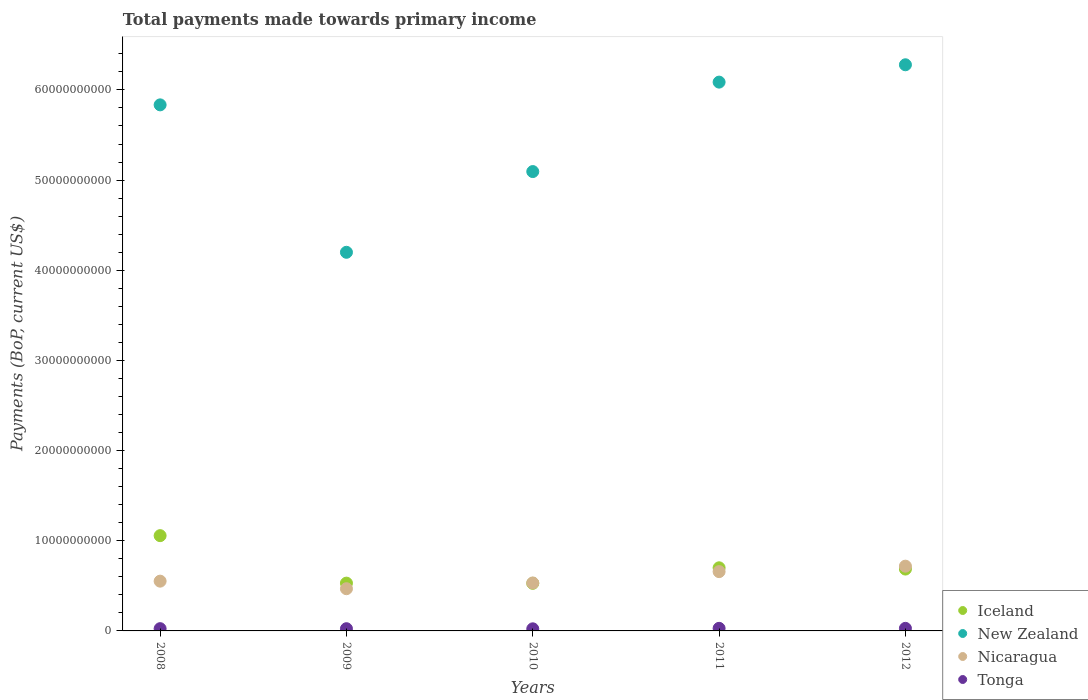What is the total payments made towards primary income in New Zealand in 2009?
Make the answer very short. 4.20e+1. Across all years, what is the maximum total payments made towards primary income in Tonga?
Your answer should be very brief. 2.87e+08. Across all years, what is the minimum total payments made towards primary income in New Zealand?
Make the answer very short. 4.20e+1. What is the total total payments made towards primary income in New Zealand in the graph?
Offer a very short reply. 2.75e+11. What is the difference between the total payments made towards primary income in Iceland in 2008 and that in 2009?
Provide a succinct answer. 5.27e+09. What is the difference between the total payments made towards primary income in Nicaragua in 2011 and the total payments made towards primary income in Tonga in 2012?
Provide a succinct answer. 6.29e+09. What is the average total payments made towards primary income in New Zealand per year?
Provide a succinct answer. 5.50e+1. In the year 2009, what is the difference between the total payments made towards primary income in New Zealand and total payments made towards primary income in Nicaragua?
Provide a succinct answer. 3.73e+1. What is the ratio of the total payments made towards primary income in Tonga in 2009 to that in 2012?
Make the answer very short. 0.86. Is the difference between the total payments made towards primary income in New Zealand in 2010 and 2012 greater than the difference between the total payments made towards primary income in Nicaragua in 2010 and 2012?
Provide a short and direct response. No. What is the difference between the highest and the second highest total payments made towards primary income in Tonga?
Keep it short and to the point. 2.66e+06. What is the difference between the highest and the lowest total payments made towards primary income in New Zealand?
Your answer should be very brief. 2.08e+1. Is the sum of the total payments made towards primary income in Nicaragua in 2010 and 2011 greater than the maximum total payments made towards primary income in Tonga across all years?
Keep it short and to the point. Yes. Is it the case that in every year, the sum of the total payments made towards primary income in New Zealand and total payments made towards primary income in Iceland  is greater than the total payments made towards primary income in Tonga?
Provide a succinct answer. Yes. Does the total payments made towards primary income in New Zealand monotonically increase over the years?
Your answer should be compact. No. How many dotlines are there?
Your answer should be compact. 4. How many years are there in the graph?
Offer a terse response. 5. Does the graph contain grids?
Provide a succinct answer. No. Where does the legend appear in the graph?
Your response must be concise. Bottom right. How are the legend labels stacked?
Give a very brief answer. Vertical. What is the title of the graph?
Provide a succinct answer. Total payments made towards primary income. Does "Vietnam" appear as one of the legend labels in the graph?
Keep it short and to the point. No. What is the label or title of the X-axis?
Ensure brevity in your answer.  Years. What is the label or title of the Y-axis?
Provide a succinct answer. Payments (BoP, current US$). What is the Payments (BoP, current US$) in Iceland in 2008?
Make the answer very short. 1.06e+1. What is the Payments (BoP, current US$) in New Zealand in 2008?
Offer a terse response. 5.83e+1. What is the Payments (BoP, current US$) of Nicaragua in 2008?
Give a very brief answer. 5.52e+09. What is the Payments (BoP, current US$) in Tonga in 2008?
Your answer should be compact. 2.51e+08. What is the Payments (BoP, current US$) of Iceland in 2009?
Give a very brief answer. 5.30e+09. What is the Payments (BoP, current US$) of New Zealand in 2009?
Keep it short and to the point. 4.20e+1. What is the Payments (BoP, current US$) of Nicaragua in 2009?
Ensure brevity in your answer.  4.68e+09. What is the Payments (BoP, current US$) in Tonga in 2009?
Your answer should be compact. 2.45e+08. What is the Payments (BoP, current US$) of Iceland in 2010?
Offer a terse response. 5.28e+09. What is the Payments (BoP, current US$) of New Zealand in 2010?
Make the answer very short. 5.09e+1. What is the Payments (BoP, current US$) in Nicaragua in 2010?
Your response must be concise. 5.32e+09. What is the Payments (BoP, current US$) of Tonga in 2010?
Offer a terse response. 2.33e+08. What is the Payments (BoP, current US$) in Iceland in 2011?
Provide a short and direct response. 7.00e+09. What is the Payments (BoP, current US$) of New Zealand in 2011?
Offer a terse response. 6.09e+1. What is the Payments (BoP, current US$) of Nicaragua in 2011?
Your answer should be very brief. 6.58e+09. What is the Payments (BoP, current US$) in Tonga in 2011?
Provide a succinct answer. 2.87e+08. What is the Payments (BoP, current US$) in Iceland in 2012?
Make the answer very short. 6.86e+09. What is the Payments (BoP, current US$) of New Zealand in 2012?
Offer a terse response. 6.28e+1. What is the Payments (BoP, current US$) of Nicaragua in 2012?
Provide a short and direct response. 7.18e+09. What is the Payments (BoP, current US$) of Tonga in 2012?
Your answer should be very brief. 2.85e+08. Across all years, what is the maximum Payments (BoP, current US$) in Iceland?
Provide a succinct answer. 1.06e+1. Across all years, what is the maximum Payments (BoP, current US$) of New Zealand?
Provide a succinct answer. 6.28e+1. Across all years, what is the maximum Payments (BoP, current US$) of Nicaragua?
Provide a succinct answer. 7.18e+09. Across all years, what is the maximum Payments (BoP, current US$) in Tonga?
Ensure brevity in your answer.  2.87e+08. Across all years, what is the minimum Payments (BoP, current US$) in Iceland?
Your answer should be compact. 5.28e+09. Across all years, what is the minimum Payments (BoP, current US$) of New Zealand?
Keep it short and to the point. 4.20e+1. Across all years, what is the minimum Payments (BoP, current US$) of Nicaragua?
Give a very brief answer. 4.68e+09. Across all years, what is the minimum Payments (BoP, current US$) of Tonga?
Your answer should be very brief. 2.33e+08. What is the total Payments (BoP, current US$) of Iceland in the graph?
Your answer should be compact. 3.50e+1. What is the total Payments (BoP, current US$) of New Zealand in the graph?
Your answer should be compact. 2.75e+11. What is the total Payments (BoP, current US$) in Nicaragua in the graph?
Your answer should be compact. 2.93e+1. What is the total Payments (BoP, current US$) in Tonga in the graph?
Offer a terse response. 1.30e+09. What is the difference between the Payments (BoP, current US$) of Iceland in 2008 and that in 2009?
Your answer should be compact. 5.27e+09. What is the difference between the Payments (BoP, current US$) in New Zealand in 2008 and that in 2009?
Your response must be concise. 1.64e+1. What is the difference between the Payments (BoP, current US$) in Nicaragua in 2008 and that in 2009?
Keep it short and to the point. 8.38e+08. What is the difference between the Payments (BoP, current US$) of Tonga in 2008 and that in 2009?
Provide a succinct answer. 5.78e+06. What is the difference between the Payments (BoP, current US$) of Iceland in 2008 and that in 2010?
Provide a short and direct response. 5.29e+09. What is the difference between the Payments (BoP, current US$) in New Zealand in 2008 and that in 2010?
Your answer should be very brief. 7.40e+09. What is the difference between the Payments (BoP, current US$) in Nicaragua in 2008 and that in 2010?
Provide a short and direct response. 2.00e+08. What is the difference between the Payments (BoP, current US$) of Tonga in 2008 and that in 2010?
Keep it short and to the point. 1.86e+07. What is the difference between the Payments (BoP, current US$) in Iceland in 2008 and that in 2011?
Keep it short and to the point. 3.57e+09. What is the difference between the Payments (BoP, current US$) of New Zealand in 2008 and that in 2011?
Provide a succinct answer. -2.52e+09. What is the difference between the Payments (BoP, current US$) in Nicaragua in 2008 and that in 2011?
Ensure brevity in your answer.  -1.06e+09. What is the difference between the Payments (BoP, current US$) in Tonga in 2008 and that in 2011?
Give a very brief answer. -3.60e+07. What is the difference between the Payments (BoP, current US$) in Iceland in 2008 and that in 2012?
Your answer should be compact. 3.71e+09. What is the difference between the Payments (BoP, current US$) of New Zealand in 2008 and that in 2012?
Ensure brevity in your answer.  -4.45e+09. What is the difference between the Payments (BoP, current US$) in Nicaragua in 2008 and that in 2012?
Give a very brief answer. -1.66e+09. What is the difference between the Payments (BoP, current US$) in Tonga in 2008 and that in 2012?
Provide a short and direct response. -3.34e+07. What is the difference between the Payments (BoP, current US$) of Iceland in 2009 and that in 2010?
Ensure brevity in your answer.  2.02e+07. What is the difference between the Payments (BoP, current US$) in New Zealand in 2009 and that in 2010?
Give a very brief answer. -8.95e+09. What is the difference between the Payments (BoP, current US$) of Nicaragua in 2009 and that in 2010?
Offer a terse response. -6.38e+08. What is the difference between the Payments (BoP, current US$) in Tonga in 2009 and that in 2010?
Give a very brief answer. 1.28e+07. What is the difference between the Payments (BoP, current US$) of Iceland in 2009 and that in 2011?
Your answer should be compact. -1.70e+09. What is the difference between the Payments (BoP, current US$) in New Zealand in 2009 and that in 2011?
Provide a succinct answer. -1.89e+1. What is the difference between the Payments (BoP, current US$) in Nicaragua in 2009 and that in 2011?
Make the answer very short. -1.90e+09. What is the difference between the Payments (BoP, current US$) in Tonga in 2009 and that in 2011?
Provide a short and direct response. -4.18e+07. What is the difference between the Payments (BoP, current US$) in Iceland in 2009 and that in 2012?
Provide a succinct answer. -1.56e+09. What is the difference between the Payments (BoP, current US$) of New Zealand in 2009 and that in 2012?
Provide a short and direct response. -2.08e+1. What is the difference between the Payments (BoP, current US$) of Nicaragua in 2009 and that in 2012?
Your answer should be very brief. -2.50e+09. What is the difference between the Payments (BoP, current US$) in Tonga in 2009 and that in 2012?
Offer a terse response. -3.91e+07. What is the difference between the Payments (BoP, current US$) of Iceland in 2010 and that in 2011?
Keep it short and to the point. -1.72e+09. What is the difference between the Payments (BoP, current US$) in New Zealand in 2010 and that in 2011?
Give a very brief answer. -9.92e+09. What is the difference between the Payments (BoP, current US$) of Nicaragua in 2010 and that in 2011?
Offer a very short reply. -1.26e+09. What is the difference between the Payments (BoP, current US$) of Tonga in 2010 and that in 2011?
Provide a succinct answer. -5.46e+07. What is the difference between the Payments (BoP, current US$) of Iceland in 2010 and that in 2012?
Offer a terse response. -1.58e+09. What is the difference between the Payments (BoP, current US$) of New Zealand in 2010 and that in 2012?
Provide a succinct answer. -1.18e+1. What is the difference between the Payments (BoP, current US$) in Nicaragua in 2010 and that in 2012?
Your answer should be compact. -1.86e+09. What is the difference between the Payments (BoP, current US$) of Tonga in 2010 and that in 2012?
Offer a terse response. -5.19e+07. What is the difference between the Payments (BoP, current US$) of Iceland in 2011 and that in 2012?
Keep it short and to the point. 1.41e+08. What is the difference between the Payments (BoP, current US$) in New Zealand in 2011 and that in 2012?
Ensure brevity in your answer.  -1.92e+09. What is the difference between the Payments (BoP, current US$) in Nicaragua in 2011 and that in 2012?
Provide a succinct answer. -6.07e+08. What is the difference between the Payments (BoP, current US$) of Tonga in 2011 and that in 2012?
Offer a very short reply. 2.66e+06. What is the difference between the Payments (BoP, current US$) of Iceland in 2008 and the Payments (BoP, current US$) of New Zealand in 2009?
Your answer should be compact. -3.14e+1. What is the difference between the Payments (BoP, current US$) of Iceland in 2008 and the Payments (BoP, current US$) of Nicaragua in 2009?
Make the answer very short. 5.89e+09. What is the difference between the Payments (BoP, current US$) in Iceland in 2008 and the Payments (BoP, current US$) in Tonga in 2009?
Your answer should be compact. 1.03e+1. What is the difference between the Payments (BoP, current US$) in New Zealand in 2008 and the Payments (BoP, current US$) in Nicaragua in 2009?
Your answer should be compact. 5.37e+1. What is the difference between the Payments (BoP, current US$) in New Zealand in 2008 and the Payments (BoP, current US$) in Tonga in 2009?
Provide a succinct answer. 5.81e+1. What is the difference between the Payments (BoP, current US$) in Nicaragua in 2008 and the Payments (BoP, current US$) in Tonga in 2009?
Ensure brevity in your answer.  5.27e+09. What is the difference between the Payments (BoP, current US$) in Iceland in 2008 and the Payments (BoP, current US$) in New Zealand in 2010?
Give a very brief answer. -4.04e+1. What is the difference between the Payments (BoP, current US$) in Iceland in 2008 and the Payments (BoP, current US$) in Nicaragua in 2010?
Offer a very short reply. 5.25e+09. What is the difference between the Payments (BoP, current US$) of Iceland in 2008 and the Payments (BoP, current US$) of Tonga in 2010?
Give a very brief answer. 1.03e+1. What is the difference between the Payments (BoP, current US$) in New Zealand in 2008 and the Payments (BoP, current US$) in Nicaragua in 2010?
Your answer should be very brief. 5.30e+1. What is the difference between the Payments (BoP, current US$) of New Zealand in 2008 and the Payments (BoP, current US$) of Tonga in 2010?
Keep it short and to the point. 5.81e+1. What is the difference between the Payments (BoP, current US$) of Nicaragua in 2008 and the Payments (BoP, current US$) of Tonga in 2010?
Keep it short and to the point. 5.29e+09. What is the difference between the Payments (BoP, current US$) in Iceland in 2008 and the Payments (BoP, current US$) in New Zealand in 2011?
Your answer should be very brief. -5.03e+1. What is the difference between the Payments (BoP, current US$) of Iceland in 2008 and the Payments (BoP, current US$) of Nicaragua in 2011?
Give a very brief answer. 3.99e+09. What is the difference between the Payments (BoP, current US$) in Iceland in 2008 and the Payments (BoP, current US$) in Tonga in 2011?
Provide a succinct answer. 1.03e+1. What is the difference between the Payments (BoP, current US$) of New Zealand in 2008 and the Payments (BoP, current US$) of Nicaragua in 2011?
Provide a succinct answer. 5.18e+1. What is the difference between the Payments (BoP, current US$) of New Zealand in 2008 and the Payments (BoP, current US$) of Tonga in 2011?
Make the answer very short. 5.81e+1. What is the difference between the Payments (BoP, current US$) of Nicaragua in 2008 and the Payments (BoP, current US$) of Tonga in 2011?
Make the answer very short. 5.23e+09. What is the difference between the Payments (BoP, current US$) of Iceland in 2008 and the Payments (BoP, current US$) of New Zealand in 2012?
Offer a very short reply. -5.22e+1. What is the difference between the Payments (BoP, current US$) of Iceland in 2008 and the Payments (BoP, current US$) of Nicaragua in 2012?
Provide a short and direct response. 3.38e+09. What is the difference between the Payments (BoP, current US$) in Iceland in 2008 and the Payments (BoP, current US$) in Tonga in 2012?
Your answer should be compact. 1.03e+1. What is the difference between the Payments (BoP, current US$) in New Zealand in 2008 and the Payments (BoP, current US$) in Nicaragua in 2012?
Provide a short and direct response. 5.12e+1. What is the difference between the Payments (BoP, current US$) in New Zealand in 2008 and the Payments (BoP, current US$) in Tonga in 2012?
Offer a terse response. 5.81e+1. What is the difference between the Payments (BoP, current US$) of Nicaragua in 2008 and the Payments (BoP, current US$) of Tonga in 2012?
Make the answer very short. 5.23e+09. What is the difference between the Payments (BoP, current US$) in Iceland in 2009 and the Payments (BoP, current US$) in New Zealand in 2010?
Give a very brief answer. -4.56e+1. What is the difference between the Payments (BoP, current US$) in Iceland in 2009 and the Payments (BoP, current US$) in Nicaragua in 2010?
Ensure brevity in your answer.  -1.92e+07. What is the difference between the Payments (BoP, current US$) of Iceland in 2009 and the Payments (BoP, current US$) of Tonga in 2010?
Make the answer very short. 5.07e+09. What is the difference between the Payments (BoP, current US$) of New Zealand in 2009 and the Payments (BoP, current US$) of Nicaragua in 2010?
Make the answer very short. 3.67e+1. What is the difference between the Payments (BoP, current US$) in New Zealand in 2009 and the Payments (BoP, current US$) in Tonga in 2010?
Make the answer very short. 4.18e+1. What is the difference between the Payments (BoP, current US$) of Nicaragua in 2009 and the Payments (BoP, current US$) of Tonga in 2010?
Provide a short and direct response. 4.45e+09. What is the difference between the Payments (BoP, current US$) in Iceland in 2009 and the Payments (BoP, current US$) in New Zealand in 2011?
Make the answer very short. -5.56e+1. What is the difference between the Payments (BoP, current US$) of Iceland in 2009 and the Payments (BoP, current US$) of Nicaragua in 2011?
Give a very brief answer. -1.28e+09. What is the difference between the Payments (BoP, current US$) of Iceland in 2009 and the Payments (BoP, current US$) of Tonga in 2011?
Offer a terse response. 5.01e+09. What is the difference between the Payments (BoP, current US$) of New Zealand in 2009 and the Payments (BoP, current US$) of Nicaragua in 2011?
Your answer should be very brief. 3.54e+1. What is the difference between the Payments (BoP, current US$) in New Zealand in 2009 and the Payments (BoP, current US$) in Tonga in 2011?
Keep it short and to the point. 4.17e+1. What is the difference between the Payments (BoP, current US$) in Nicaragua in 2009 and the Payments (BoP, current US$) in Tonga in 2011?
Keep it short and to the point. 4.39e+09. What is the difference between the Payments (BoP, current US$) in Iceland in 2009 and the Payments (BoP, current US$) in New Zealand in 2012?
Make the answer very short. -5.75e+1. What is the difference between the Payments (BoP, current US$) of Iceland in 2009 and the Payments (BoP, current US$) of Nicaragua in 2012?
Make the answer very short. -1.88e+09. What is the difference between the Payments (BoP, current US$) of Iceland in 2009 and the Payments (BoP, current US$) of Tonga in 2012?
Provide a succinct answer. 5.02e+09. What is the difference between the Payments (BoP, current US$) in New Zealand in 2009 and the Payments (BoP, current US$) in Nicaragua in 2012?
Ensure brevity in your answer.  3.48e+1. What is the difference between the Payments (BoP, current US$) in New Zealand in 2009 and the Payments (BoP, current US$) in Tonga in 2012?
Provide a succinct answer. 4.17e+1. What is the difference between the Payments (BoP, current US$) of Nicaragua in 2009 and the Payments (BoP, current US$) of Tonga in 2012?
Your response must be concise. 4.40e+09. What is the difference between the Payments (BoP, current US$) of Iceland in 2010 and the Payments (BoP, current US$) of New Zealand in 2011?
Keep it short and to the point. -5.56e+1. What is the difference between the Payments (BoP, current US$) in Iceland in 2010 and the Payments (BoP, current US$) in Nicaragua in 2011?
Your answer should be compact. -1.30e+09. What is the difference between the Payments (BoP, current US$) of Iceland in 2010 and the Payments (BoP, current US$) of Tonga in 2011?
Offer a terse response. 4.99e+09. What is the difference between the Payments (BoP, current US$) of New Zealand in 2010 and the Payments (BoP, current US$) of Nicaragua in 2011?
Make the answer very short. 4.44e+1. What is the difference between the Payments (BoP, current US$) in New Zealand in 2010 and the Payments (BoP, current US$) in Tonga in 2011?
Keep it short and to the point. 5.07e+1. What is the difference between the Payments (BoP, current US$) in Nicaragua in 2010 and the Payments (BoP, current US$) in Tonga in 2011?
Your answer should be compact. 5.03e+09. What is the difference between the Payments (BoP, current US$) of Iceland in 2010 and the Payments (BoP, current US$) of New Zealand in 2012?
Provide a short and direct response. -5.75e+1. What is the difference between the Payments (BoP, current US$) of Iceland in 2010 and the Payments (BoP, current US$) of Nicaragua in 2012?
Your answer should be very brief. -1.90e+09. What is the difference between the Payments (BoP, current US$) of Iceland in 2010 and the Payments (BoP, current US$) of Tonga in 2012?
Provide a succinct answer. 5.00e+09. What is the difference between the Payments (BoP, current US$) in New Zealand in 2010 and the Payments (BoP, current US$) in Nicaragua in 2012?
Ensure brevity in your answer.  4.38e+1. What is the difference between the Payments (BoP, current US$) of New Zealand in 2010 and the Payments (BoP, current US$) of Tonga in 2012?
Provide a succinct answer. 5.07e+1. What is the difference between the Payments (BoP, current US$) in Nicaragua in 2010 and the Payments (BoP, current US$) in Tonga in 2012?
Your answer should be compact. 5.03e+09. What is the difference between the Payments (BoP, current US$) in Iceland in 2011 and the Payments (BoP, current US$) in New Zealand in 2012?
Make the answer very short. -5.58e+1. What is the difference between the Payments (BoP, current US$) of Iceland in 2011 and the Payments (BoP, current US$) of Nicaragua in 2012?
Your answer should be very brief. -1.83e+08. What is the difference between the Payments (BoP, current US$) in Iceland in 2011 and the Payments (BoP, current US$) in Tonga in 2012?
Your answer should be very brief. 6.72e+09. What is the difference between the Payments (BoP, current US$) of New Zealand in 2011 and the Payments (BoP, current US$) of Nicaragua in 2012?
Make the answer very short. 5.37e+1. What is the difference between the Payments (BoP, current US$) of New Zealand in 2011 and the Payments (BoP, current US$) of Tonga in 2012?
Keep it short and to the point. 6.06e+1. What is the difference between the Payments (BoP, current US$) in Nicaragua in 2011 and the Payments (BoP, current US$) in Tonga in 2012?
Your answer should be compact. 6.29e+09. What is the average Payments (BoP, current US$) in Iceland per year?
Keep it short and to the point. 7.00e+09. What is the average Payments (BoP, current US$) in New Zealand per year?
Make the answer very short. 5.50e+1. What is the average Payments (BoP, current US$) of Nicaragua per year?
Provide a succinct answer. 5.86e+09. What is the average Payments (BoP, current US$) of Tonga per year?
Give a very brief answer. 2.60e+08. In the year 2008, what is the difference between the Payments (BoP, current US$) in Iceland and Payments (BoP, current US$) in New Zealand?
Provide a short and direct response. -4.78e+1. In the year 2008, what is the difference between the Payments (BoP, current US$) of Iceland and Payments (BoP, current US$) of Nicaragua?
Your answer should be very brief. 5.05e+09. In the year 2008, what is the difference between the Payments (BoP, current US$) of Iceland and Payments (BoP, current US$) of Tonga?
Your response must be concise. 1.03e+1. In the year 2008, what is the difference between the Payments (BoP, current US$) of New Zealand and Payments (BoP, current US$) of Nicaragua?
Keep it short and to the point. 5.28e+1. In the year 2008, what is the difference between the Payments (BoP, current US$) in New Zealand and Payments (BoP, current US$) in Tonga?
Offer a very short reply. 5.81e+1. In the year 2008, what is the difference between the Payments (BoP, current US$) in Nicaragua and Payments (BoP, current US$) in Tonga?
Provide a succinct answer. 5.27e+09. In the year 2009, what is the difference between the Payments (BoP, current US$) in Iceland and Payments (BoP, current US$) in New Zealand?
Ensure brevity in your answer.  -3.67e+1. In the year 2009, what is the difference between the Payments (BoP, current US$) in Iceland and Payments (BoP, current US$) in Nicaragua?
Ensure brevity in your answer.  6.19e+08. In the year 2009, what is the difference between the Payments (BoP, current US$) in Iceland and Payments (BoP, current US$) in Tonga?
Your answer should be compact. 5.05e+09. In the year 2009, what is the difference between the Payments (BoP, current US$) of New Zealand and Payments (BoP, current US$) of Nicaragua?
Your response must be concise. 3.73e+1. In the year 2009, what is the difference between the Payments (BoP, current US$) in New Zealand and Payments (BoP, current US$) in Tonga?
Make the answer very short. 4.17e+1. In the year 2009, what is the difference between the Payments (BoP, current US$) of Nicaragua and Payments (BoP, current US$) of Tonga?
Make the answer very short. 4.44e+09. In the year 2010, what is the difference between the Payments (BoP, current US$) in Iceland and Payments (BoP, current US$) in New Zealand?
Keep it short and to the point. -4.57e+1. In the year 2010, what is the difference between the Payments (BoP, current US$) of Iceland and Payments (BoP, current US$) of Nicaragua?
Make the answer very short. -3.94e+07. In the year 2010, what is the difference between the Payments (BoP, current US$) of Iceland and Payments (BoP, current US$) of Tonga?
Provide a short and direct response. 5.05e+09. In the year 2010, what is the difference between the Payments (BoP, current US$) in New Zealand and Payments (BoP, current US$) in Nicaragua?
Your answer should be compact. 4.56e+1. In the year 2010, what is the difference between the Payments (BoP, current US$) of New Zealand and Payments (BoP, current US$) of Tonga?
Your response must be concise. 5.07e+1. In the year 2010, what is the difference between the Payments (BoP, current US$) of Nicaragua and Payments (BoP, current US$) of Tonga?
Provide a succinct answer. 5.09e+09. In the year 2011, what is the difference between the Payments (BoP, current US$) of Iceland and Payments (BoP, current US$) of New Zealand?
Offer a very short reply. -5.39e+1. In the year 2011, what is the difference between the Payments (BoP, current US$) in Iceland and Payments (BoP, current US$) in Nicaragua?
Your answer should be compact. 4.24e+08. In the year 2011, what is the difference between the Payments (BoP, current US$) in Iceland and Payments (BoP, current US$) in Tonga?
Offer a very short reply. 6.71e+09. In the year 2011, what is the difference between the Payments (BoP, current US$) in New Zealand and Payments (BoP, current US$) in Nicaragua?
Your answer should be very brief. 5.43e+1. In the year 2011, what is the difference between the Payments (BoP, current US$) of New Zealand and Payments (BoP, current US$) of Tonga?
Provide a short and direct response. 6.06e+1. In the year 2011, what is the difference between the Payments (BoP, current US$) of Nicaragua and Payments (BoP, current US$) of Tonga?
Offer a terse response. 6.29e+09. In the year 2012, what is the difference between the Payments (BoP, current US$) of Iceland and Payments (BoP, current US$) of New Zealand?
Keep it short and to the point. -5.59e+1. In the year 2012, what is the difference between the Payments (BoP, current US$) of Iceland and Payments (BoP, current US$) of Nicaragua?
Your response must be concise. -3.24e+08. In the year 2012, what is the difference between the Payments (BoP, current US$) in Iceland and Payments (BoP, current US$) in Tonga?
Ensure brevity in your answer.  6.57e+09. In the year 2012, what is the difference between the Payments (BoP, current US$) in New Zealand and Payments (BoP, current US$) in Nicaragua?
Your answer should be compact. 5.56e+1. In the year 2012, what is the difference between the Payments (BoP, current US$) of New Zealand and Payments (BoP, current US$) of Tonga?
Make the answer very short. 6.25e+1. In the year 2012, what is the difference between the Payments (BoP, current US$) of Nicaragua and Payments (BoP, current US$) of Tonga?
Keep it short and to the point. 6.90e+09. What is the ratio of the Payments (BoP, current US$) of Iceland in 2008 to that in 2009?
Give a very brief answer. 1.99. What is the ratio of the Payments (BoP, current US$) of New Zealand in 2008 to that in 2009?
Your response must be concise. 1.39. What is the ratio of the Payments (BoP, current US$) in Nicaragua in 2008 to that in 2009?
Your answer should be very brief. 1.18. What is the ratio of the Payments (BoP, current US$) in Tonga in 2008 to that in 2009?
Ensure brevity in your answer.  1.02. What is the ratio of the Payments (BoP, current US$) of Iceland in 2008 to that in 2010?
Give a very brief answer. 2. What is the ratio of the Payments (BoP, current US$) of New Zealand in 2008 to that in 2010?
Your answer should be compact. 1.15. What is the ratio of the Payments (BoP, current US$) of Nicaragua in 2008 to that in 2010?
Provide a short and direct response. 1.04. What is the ratio of the Payments (BoP, current US$) in Tonga in 2008 to that in 2010?
Offer a terse response. 1.08. What is the ratio of the Payments (BoP, current US$) in Iceland in 2008 to that in 2011?
Keep it short and to the point. 1.51. What is the ratio of the Payments (BoP, current US$) in New Zealand in 2008 to that in 2011?
Your answer should be compact. 0.96. What is the ratio of the Payments (BoP, current US$) in Nicaragua in 2008 to that in 2011?
Your answer should be very brief. 0.84. What is the ratio of the Payments (BoP, current US$) in Tonga in 2008 to that in 2011?
Provide a succinct answer. 0.87. What is the ratio of the Payments (BoP, current US$) of Iceland in 2008 to that in 2012?
Offer a very short reply. 1.54. What is the ratio of the Payments (BoP, current US$) of New Zealand in 2008 to that in 2012?
Make the answer very short. 0.93. What is the ratio of the Payments (BoP, current US$) in Nicaragua in 2008 to that in 2012?
Provide a short and direct response. 0.77. What is the ratio of the Payments (BoP, current US$) of Tonga in 2008 to that in 2012?
Offer a very short reply. 0.88. What is the ratio of the Payments (BoP, current US$) of New Zealand in 2009 to that in 2010?
Your answer should be very brief. 0.82. What is the ratio of the Payments (BoP, current US$) in Nicaragua in 2009 to that in 2010?
Offer a terse response. 0.88. What is the ratio of the Payments (BoP, current US$) in Tonga in 2009 to that in 2010?
Provide a short and direct response. 1.05. What is the ratio of the Payments (BoP, current US$) of Iceland in 2009 to that in 2011?
Offer a very short reply. 0.76. What is the ratio of the Payments (BoP, current US$) in New Zealand in 2009 to that in 2011?
Provide a short and direct response. 0.69. What is the ratio of the Payments (BoP, current US$) of Nicaragua in 2009 to that in 2011?
Ensure brevity in your answer.  0.71. What is the ratio of the Payments (BoP, current US$) in Tonga in 2009 to that in 2011?
Give a very brief answer. 0.85. What is the ratio of the Payments (BoP, current US$) of Iceland in 2009 to that in 2012?
Provide a succinct answer. 0.77. What is the ratio of the Payments (BoP, current US$) in New Zealand in 2009 to that in 2012?
Offer a very short reply. 0.67. What is the ratio of the Payments (BoP, current US$) in Nicaragua in 2009 to that in 2012?
Ensure brevity in your answer.  0.65. What is the ratio of the Payments (BoP, current US$) in Tonga in 2009 to that in 2012?
Your response must be concise. 0.86. What is the ratio of the Payments (BoP, current US$) of Iceland in 2010 to that in 2011?
Provide a short and direct response. 0.75. What is the ratio of the Payments (BoP, current US$) in New Zealand in 2010 to that in 2011?
Your answer should be compact. 0.84. What is the ratio of the Payments (BoP, current US$) in Nicaragua in 2010 to that in 2011?
Give a very brief answer. 0.81. What is the ratio of the Payments (BoP, current US$) in Tonga in 2010 to that in 2011?
Provide a succinct answer. 0.81. What is the ratio of the Payments (BoP, current US$) in Iceland in 2010 to that in 2012?
Offer a terse response. 0.77. What is the ratio of the Payments (BoP, current US$) in New Zealand in 2010 to that in 2012?
Your answer should be compact. 0.81. What is the ratio of the Payments (BoP, current US$) of Nicaragua in 2010 to that in 2012?
Provide a short and direct response. 0.74. What is the ratio of the Payments (BoP, current US$) in Tonga in 2010 to that in 2012?
Your response must be concise. 0.82. What is the ratio of the Payments (BoP, current US$) in Iceland in 2011 to that in 2012?
Give a very brief answer. 1.02. What is the ratio of the Payments (BoP, current US$) in New Zealand in 2011 to that in 2012?
Offer a terse response. 0.97. What is the ratio of the Payments (BoP, current US$) of Nicaragua in 2011 to that in 2012?
Offer a very short reply. 0.92. What is the ratio of the Payments (BoP, current US$) of Tonga in 2011 to that in 2012?
Your answer should be very brief. 1.01. What is the difference between the highest and the second highest Payments (BoP, current US$) of Iceland?
Offer a very short reply. 3.57e+09. What is the difference between the highest and the second highest Payments (BoP, current US$) in New Zealand?
Your answer should be compact. 1.92e+09. What is the difference between the highest and the second highest Payments (BoP, current US$) in Nicaragua?
Make the answer very short. 6.07e+08. What is the difference between the highest and the second highest Payments (BoP, current US$) in Tonga?
Provide a succinct answer. 2.66e+06. What is the difference between the highest and the lowest Payments (BoP, current US$) of Iceland?
Offer a terse response. 5.29e+09. What is the difference between the highest and the lowest Payments (BoP, current US$) in New Zealand?
Ensure brevity in your answer.  2.08e+1. What is the difference between the highest and the lowest Payments (BoP, current US$) in Nicaragua?
Ensure brevity in your answer.  2.50e+09. What is the difference between the highest and the lowest Payments (BoP, current US$) of Tonga?
Provide a short and direct response. 5.46e+07. 